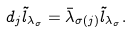<formula> <loc_0><loc_0><loc_500><loc_500>d _ { j } \tilde { l } _ { \lambda _ { \sigma } } = \bar { \lambda } _ { \sigma ( j ) } \tilde { l } _ { \lambda _ { \sigma } } .</formula> 